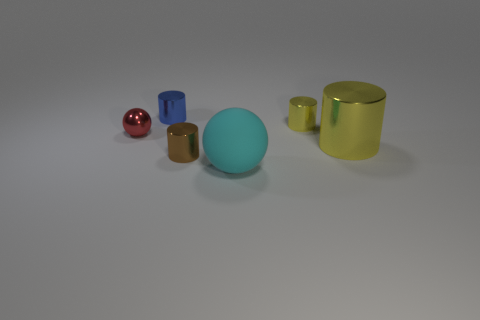How many blocks are cyan objects or tiny red objects?
Your answer should be very brief. 0. What shape is the object that is left of the brown shiny cylinder and right of the red thing?
Offer a terse response. Cylinder. Are there the same number of red shiny objects on the left side of the small sphere and objects that are left of the small yellow cylinder?
Offer a terse response. No. How many things are either big cyan blocks or small cylinders?
Offer a very short reply. 3. What is the color of the shiny sphere that is the same size as the brown cylinder?
Provide a short and direct response. Red. How many objects are metallic things on the right side of the matte thing or balls behind the cyan rubber object?
Offer a very short reply. 3. Are there the same number of small spheres right of the blue metal object and yellow cylinders?
Make the answer very short. No. Is the size of the yellow thing in front of the small yellow metal thing the same as the sphere right of the small blue cylinder?
Keep it short and to the point. Yes. What number of other things are there of the same size as the blue metallic object?
Make the answer very short. 3. Is there a big object on the left side of the large thing to the right of the tiny metallic cylinder that is to the right of the big rubber object?
Your answer should be compact. Yes. 